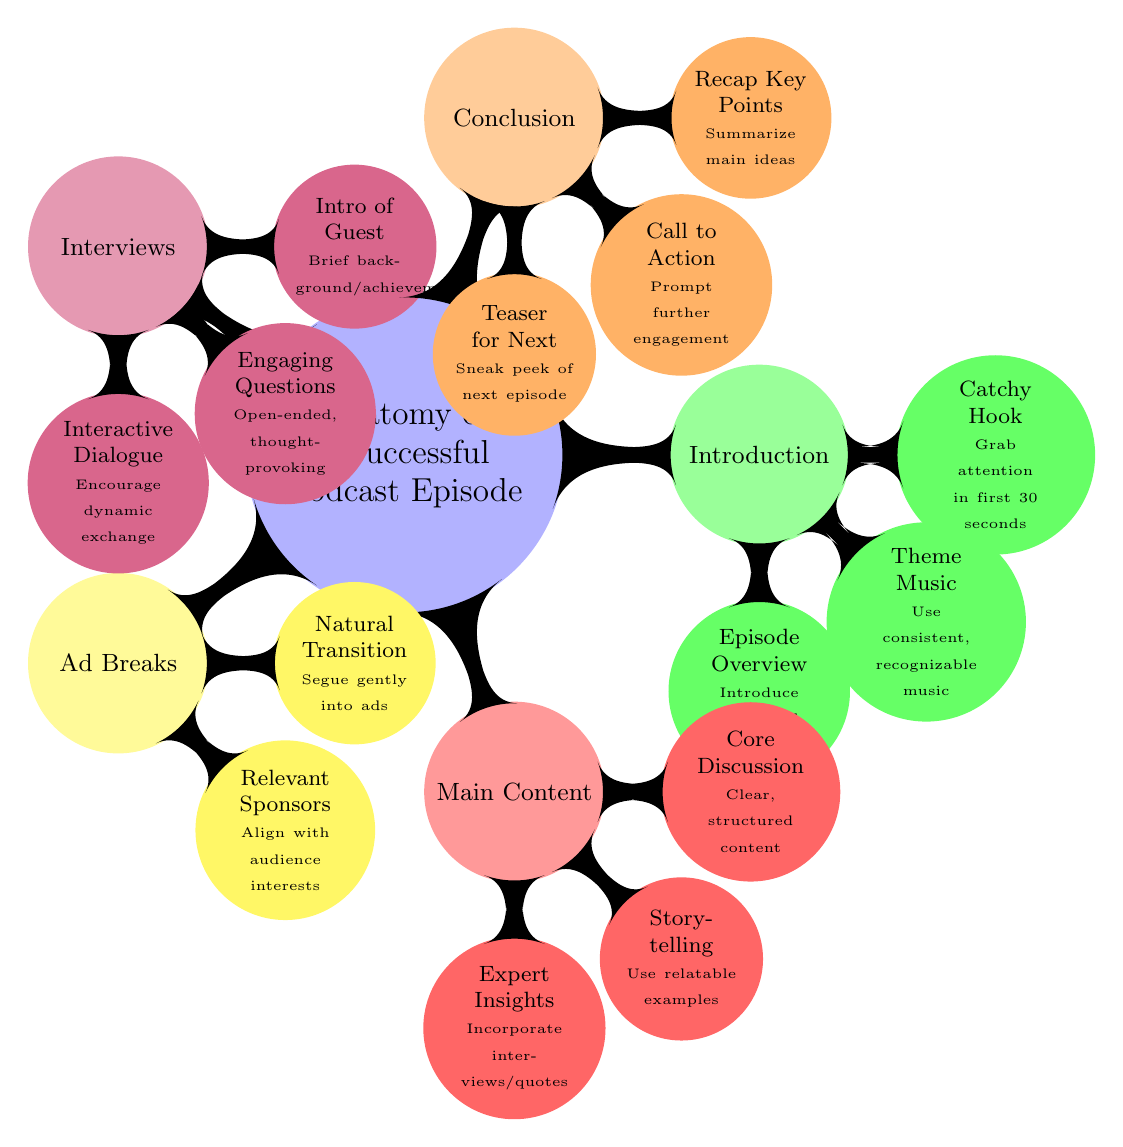What are the five main segments of a successful podcast episode? The diagram outlines five key segments: Introduction, Main Content, Ad Breaks, Interviews, and Conclusion. Each segment is distinctly categorized in the mind map.
Answer: Introduction, Main Content, Ad Breaks, Interviews, Conclusion What should be included in the intro of a podcast episode? The introduction segment includes three key components: a catchy hook to grab attention, consistent theme music, and an episode overview that introduces the topic and main points.
Answer: Catchy Hook, Theme Music, Episode Overview How many strategies are listed under Ad Breaks? The diagram specifies two strategies for Ad Breaks: Natural Transition and Relevant Sponsors. This number can be counted by considering the child nodes under Ad Breaks.
Answer: 2 What is the purpose of the conclusion segment? The conclusion segment serves three functions: it recaps key points, provides a call to action, and includes a teaser for the next episode. This is derived from the child nodes under the Conclusion segment.
Answer: Recap Key Points, Call to Action, Teaser for Next What type of questions are recommended for the interview section? The interview section suggests using engaging questions that are open-ended and thought-provoking. This is found by inspecting the content listed under the Interviews node.
Answer: Engaging Questions What strategy is suggested for transitions into Ad breaks? The diagram specifies that a natural transition is advised when moving into Ad breaks, implying that it should not feel jarring to the audience. This is indicated as a child node under Ad Breaks.
Answer: Natural Transition How is storytelling characterized in the Main Content section? Storytelling in the Main Content section is characterized by using relatable examples, which helps the audience connect with the material better. This is detailed in the child nodes of the Main Content.
Answer: Use relatable examples What is the recommended format for introducing a podcast guest? The diagram recommends a brief introduction of the guest, focusing on their background and achievements, as part of the Interviews segment. This can be directly referenced from the child nodes related to Interviews.
Answer: Brief background/achievements 